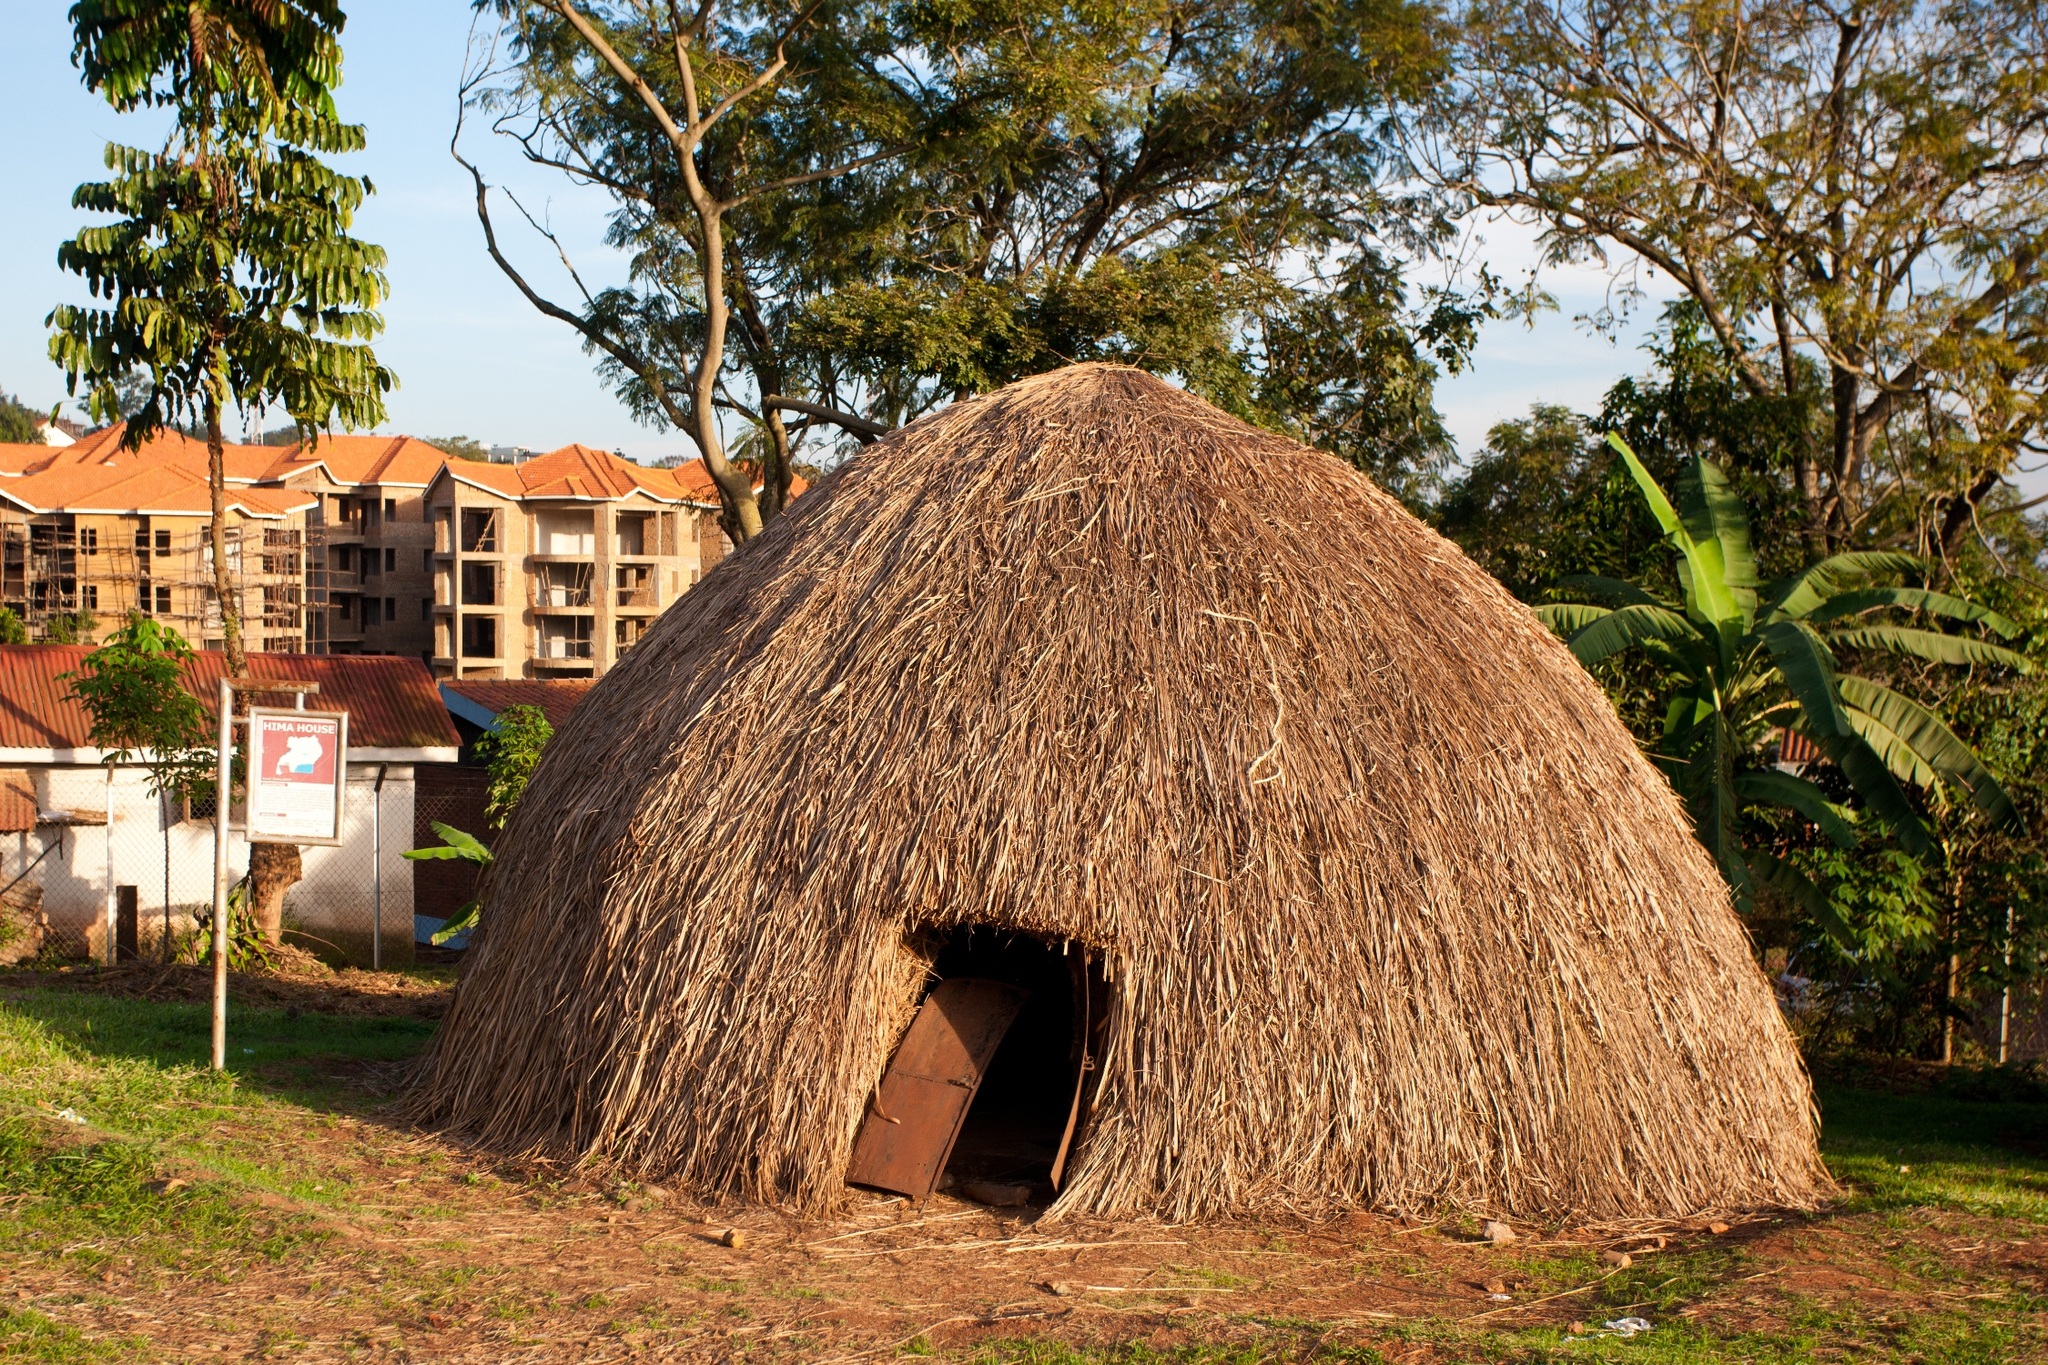What can you infer about the climate and geography of the region based on the foliage and the structure of the hut? Based on the lush greenery surrounding the hut and the presence of robust trees in the background, we can infer that the region likely experiences a warm and possibly wet climate that supports ample vegetation growth. The hut's design, with its thatched roof, is well-suited for tropical weather, providing insulation from heat and allowing rain to run off easily, preventing water retention and potential damage. 